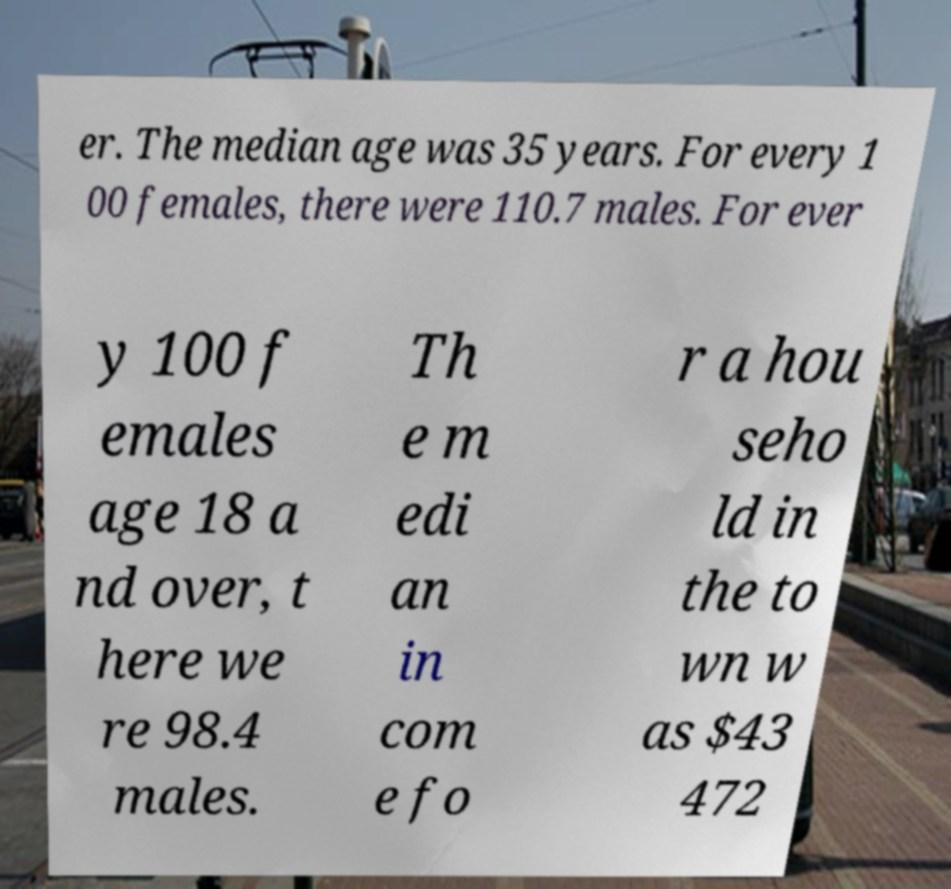I need the written content from this picture converted into text. Can you do that? er. The median age was 35 years. For every 1 00 females, there were 110.7 males. For ever y 100 f emales age 18 a nd over, t here we re 98.4 males. Th e m edi an in com e fo r a hou seho ld in the to wn w as $43 472 